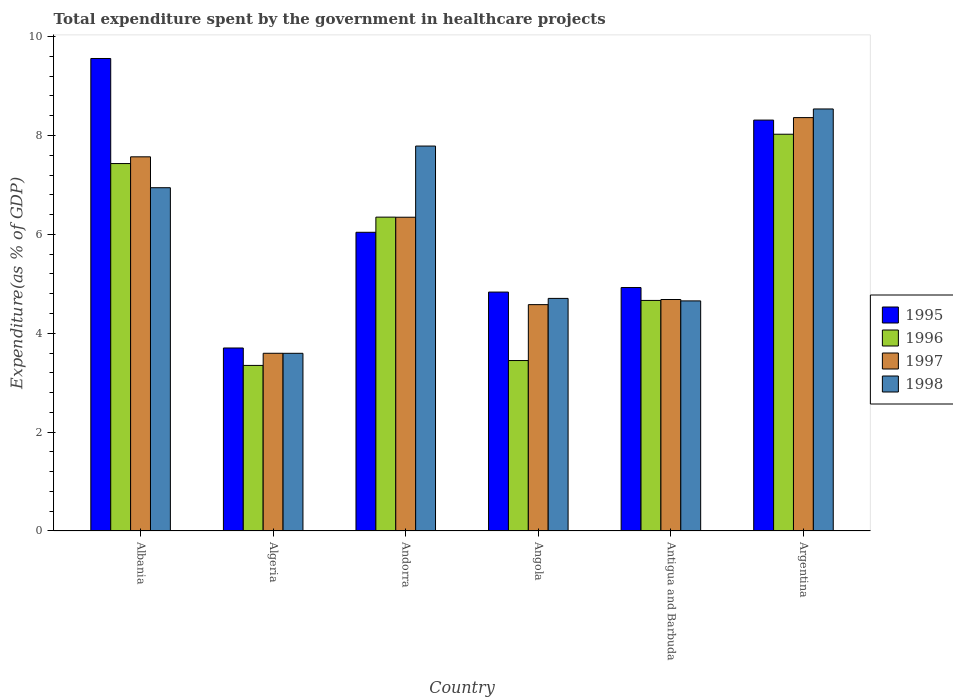How many groups of bars are there?
Your answer should be compact. 6. Are the number of bars per tick equal to the number of legend labels?
Your response must be concise. Yes. Are the number of bars on each tick of the X-axis equal?
Your answer should be compact. Yes. How many bars are there on the 5th tick from the left?
Ensure brevity in your answer.  4. How many bars are there on the 3rd tick from the right?
Offer a very short reply. 4. What is the label of the 1st group of bars from the left?
Offer a terse response. Albania. What is the total expenditure spent by the government in healthcare projects in 1995 in Argentina?
Make the answer very short. 8.31. Across all countries, what is the maximum total expenditure spent by the government in healthcare projects in 1995?
Give a very brief answer. 9.56. Across all countries, what is the minimum total expenditure spent by the government in healthcare projects in 1997?
Your response must be concise. 3.59. In which country was the total expenditure spent by the government in healthcare projects in 1997 maximum?
Offer a very short reply. Argentina. In which country was the total expenditure spent by the government in healthcare projects in 1997 minimum?
Your response must be concise. Algeria. What is the total total expenditure spent by the government in healthcare projects in 1997 in the graph?
Ensure brevity in your answer.  35.13. What is the difference between the total expenditure spent by the government in healthcare projects in 1997 in Algeria and that in Andorra?
Provide a succinct answer. -2.75. What is the difference between the total expenditure spent by the government in healthcare projects in 1996 in Andorra and the total expenditure spent by the government in healthcare projects in 1998 in Albania?
Your answer should be very brief. -0.6. What is the average total expenditure spent by the government in healthcare projects in 1997 per country?
Your answer should be very brief. 5.86. What is the difference between the total expenditure spent by the government in healthcare projects of/in 1998 and total expenditure spent by the government in healthcare projects of/in 1995 in Algeria?
Offer a terse response. -0.11. In how many countries, is the total expenditure spent by the government in healthcare projects in 1998 greater than 9.2 %?
Offer a terse response. 0. What is the ratio of the total expenditure spent by the government in healthcare projects in 1995 in Andorra to that in Argentina?
Your response must be concise. 0.73. Is the total expenditure spent by the government in healthcare projects in 1998 in Algeria less than that in Antigua and Barbuda?
Offer a terse response. Yes. What is the difference between the highest and the second highest total expenditure spent by the government in healthcare projects in 1997?
Your response must be concise. 2.02. What is the difference between the highest and the lowest total expenditure spent by the government in healthcare projects in 1997?
Ensure brevity in your answer.  4.77. Is the sum of the total expenditure spent by the government in healthcare projects in 1996 in Albania and Argentina greater than the maximum total expenditure spent by the government in healthcare projects in 1997 across all countries?
Your answer should be compact. Yes. Is it the case that in every country, the sum of the total expenditure spent by the government in healthcare projects in 1998 and total expenditure spent by the government in healthcare projects in 1995 is greater than the total expenditure spent by the government in healthcare projects in 1996?
Offer a terse response. Yes. How many bars are there?
Provide a succinct answer. 24. How many countries are there in the graph?
Your answer should be very brief. 6. What is the difference between two consecutive major ticks on the Y-axis?
Ensure brevity in your answer.  2. Are the values on the major ticks of Y-axis written in scientific E-notation?
Make the answer very short. No. How many legend labels are there?
Make the answer very short. 4. How are the legend labels stacked?
Ensure brevity in your answer.  Vertical. What is the title of the graph?
Provide a succinct answer. Total expenditure spent by the government in healthcare projects. What is the label or title of the X-axis?
Make the answer very short. Country. What is the label or title of the Y-axis?
Give a very brief answer. Expenditure(as % of GDP). What is the Expenditure(as % of GDP) in 1995 in Albania?
Offer a very short reply. 9.56. What is the Expenditure(as % of GDP) in 1996 in Albania?
Your response must be concise. 7.43. What is the Expenditure(as % of GDP) of 1997 in Albania?
Offer a very short reply. 7.57. What is the Expenditure(as % of GDP) of 1998 in Albania?
Provide a short and direct response. 6.94. What is the Expenditure(as % of GDP) in 1995 in Algeria?
Offer a very short reply. 3.7. What is the Expenditure(as % of GDP) in 1996 in Algeria?
Provide a succinct answer. 3.35. What is the Expenditure(as % of GDP) of 1997 in Algeria?
Ensure brevity in your answer.  3.59. What is the Expenditure(as % of GDP) in 1998 in Algeria?
Keep it short and to the point. 3.59. What is the Expenditure(as % of GDP) of 1995 in Andorra?
Ensure brevity in your answer.  6.04. What is the Expenditure(as % of GDP) of 1996 in Andorra?
Ensure brevity in your answer.  6.35. What is the Expenditure(as % of GDP) in 1997 in Andorra?
Keep it short and to the point. 6.35. What is the Expenditure(as % of GDP) of 1998 in Andorra?
Keep it short and to the point. 7.79. What is the Expenditure(as % of GDP) of 1995 in Angola?
Your answer should be very brief. 4.83. What is the Expenditure(as % of GDP) in 1996 in Angola?
Your answer should be compact. 3.45. What is the Expenditure(as % of GDP) of 1997 in Angola?
Keep it short and to the point. 4.58. What is the Expenditure(as % of GDP) in 1998 in Angola?
Offer a terse response. 4.7. What is the Expenditure(as % of GDP) in 1995 in Antigua and Barbuda?
Your response must be concise. 4.92. What is the Expenditure(as % of GDP) of 1996 in Antigua and Barbuda?
Your answer should be compact. 4.66. What is the Expenditure(as % of GDP) in 1997 in Antigua and Barbuda?
Give a very brief answer. 4.68. What is the Expenditure(as % of GDP) in 1998 in Antigua and Barbuda?
Provide a succinct answer. 4.65. What is the Expenditure(as % of GDP) of 1995 in Argentina?
Give a very brief answer. 8.31. What is the Expenditure(as % of GDP) of 1996 in Argentina?
Keep it short and to the point. 8.02. What is the Expenditure(as % of GDP) of 1997 in Argentina?
Give a very brief answer. 8.36. What is the Expenditure(as % of GDP) in 1998 in Argentina?
Your answer should be compact. 8.54. Across all countries, what is the maximum Expenditure(as % of GDP) of 1995?
Give a very brief answer. 9.56. Across all countries, what is the maximum Expenditure(as % of GDP) of 1996?
Provide a short and direct response. 8.02. Across all countries, what is the maximum Expenditure(as % of GDP) of 1997?
Your response must be concise. 8.36. Across all countries, what is the maximum Expenditure(as % of GDP) in 1998?
Ensure brevity in your answer.  8.54. Across all countries, what is the minimum Expenditure(as % of GDP) in 1995?
Your answer should be very brief. 3.7. Across all countries, what is the minimum Expenditure(as % of GDP) of 1996?
Your response must be concise. 3.35. Across all countries, what is the minimum Expenditure(as % of GDP) of 1997?
Your response must be concise. 3.59. Across all countries, what is the minimum Expenditure(as % of GDP) in 1998?
Offer a terse response. 3.59. What is the total Expenditure(as % of GDP) of 1995 in the graph?
Keep it short and to the point. 37.37. What is the total Expenditure(as % of GDP) of 1996 in the graph?
Your response must be concise. 33.27. What is the total Expenditure(as % of GDP) in 1997 in the graph?
Offer a very short reply. 35.13. What is the total Expenditure(as % of GDP) in 1998 in the graph?
Make the answer very short. 36.22. What is the difference between the Expenditure(as % of GDP) of 1995 in Albania and that in Algeria?
Your answer should be compact. 5.86. What is the difference between the Expenditure(as % of GDP) of 1996 in Albania and that in Algeria?
Give a very brief answer. 4.08. What is the difference between the Expenditure(as % of GDP) of 1997 in Albania and that in Algeria?
Your response must be concise. 3.97. What is the difference between the Expenditure(as % of GDP) in 1998 in Albania and that in Algeria?
Offer a terse response. 3.35. What is the difference between the Expenditure(as % of GDP) of 1995 in Albania and that in Andorra?
Offer a terse response. 3.52. What is the difference between the Expenditure(as % of GDP) of 1996 in Albania and that in Andorra?
Give a very brief answer. 1.08. What is the difference between the Expenditure(as % of GDP) of 1997 in Albania and that in Andorra?
Keep it short and to the point. 1.22. What is the difference between the Expenditure(as % of GDP) of 1998 in Albania and that in Andorra?
Your answer should be very brief. -0.84. What is the difference between the Expenditure(as % of GDP) of 1995 in Albania and that in Angola?
Provide a short and direct response. 4.72. What is the difference between the Expenditure(as % of GDP) in 1996 in Albania and that in Angola?
Offer a terse response. 3.98. What is the difference between the Expenditure(as % of GDP) in 1997 in Albania and that in Angola?
Offer a terse response. 2.99. What is the difference between the Expenditure(as % of GDP) in 1998 in Albania and that in Angola?
Keep it short and to the point. 2.24. What is the difference between the Expenditure(as % of GDP) in 1995 in Albania and that in Antigua and Barbuda?
Offer a terse response. 4.63. What is the difference between the Expenditure(as % of GDP) of 1996 in Albania and that in Antigua and Barbuda?
Your answer should be compact. 2.77. What is the difference between the Expenditure(as % of GDP) in 1997 in Albania and that in Antigua and Barbuda?
Offer a very short reply. 2.89. What is the difference between the Expenditure(as % of GDP) of 1998 in Albania and that in Antigua and Barbuda?
Ensure brevity in your answer.  2.29. What is the difference between the Expenditure(as % of GDP) in 1995 in Albania and that in Argentina?
Offer a very short reply. 1.25. What is the difference between the Expenditure(as % of GDP) of 1996 in Albania and that in Argentina?
Give a very brief answer. -0.59. What is the difference between the Expenditure(as % of GDP) in 1997 in Albania and that in Argentina?
Make the answer very short. -0.79. What is the difference between the Expenditure(as % of GDP) of 1998 in Albania and that in Argentina?
Provide a succinct answer. -1.59. What is the difference between the Expenditure(as % of GDP) in 1995 in Algeria and that in Andorra?
Your answer should be very brief. -2.34. What is the difference between the Expenditure(as % of GDP) in 1996 in Algeria and that in Andorra?
Give a very brief answer. -3. What is the difference between the Expenditure(as % of GDP) of 1997 in Algeria and that in Andorra?
Offer a very short reply. -2.75. What is the difference between the Expenditure(as % of GDP) in 1998 in Algeria and that in Andorra?
Make the answer very short. -4.19. What is the difference between the Expenditure(as % of GDP) of 1995 in Algeria and that in Angola?
Your answer should be very brief. -1.13. What is the difference between the Expenditure(as % of GDP) of 1996 in Algeria and that in Angola?
Your response must be concise. -0.1. What is the difference between the Expenditure(as % of GDP) in 1997 in Algeria and that in Angola?
Your answer should be very brief. -0.98. What is the difference between the Expenditure(as % of GDP) of 1998 in Algeria and that in Angola?
Make the answer very short. -1.11. What is the difference between the Expenditure(as % of GDP) in 1995 in Algeria and that in Antigua and Barbuda?
Offer a terse response. -1.22. What is the difference between the Expenditure(as % of GDP) in 1996 in Algeria and that in Antigua and Barbuda?
Make the answer very short. -1.31. What is the difference between the Expenditure(as % of GDP) in 1997 in Algeria and that in Antigua and Barbuda?
Offer a terse response. -1.09. What is the difference between the Expenditure(as % of GDP) in 1998 in Algeria and that in Antigua and Barbuda?
Keep it short and to the point. -1.06. What is the difference between the Expenditure(as % of GDP) of 1995 in Algeria and that in Argentina?
Provide a succinct answer. -4.61. What is the difference between the Expenditure(as % of GDP) in 1996 in Algeria and that in Argentina?
Offer a terse response. -4.68. What is the difference between the Expenditure(as % of GDP) in 1997 in Algeria and that in Argentina?
Your response must be concise. -4.77. What is the difference between the Expenditure(as % of GDP) in 1998 in Algeria and that in Argentina?
Your answer should be compact. -4.94. What is the difference between the Expenditure(as % of GDP) in 1995 in Andorra and that in Angola?
Your response must be concise. 1.21. What is the difference between the Expenditure(as % of GDP) of 1996 in Andorra and that in Angola?
Your answer should be compact. 2.9. What is the difference between the Expenditure(as % of GDP) in 1997 in Andorra and that in Angola?
Offer a very short reply. 1.77. What is the difference between the Expenditure(as % of GDP) in 1998 in Andorra and that in Angola?
Provide a succinct answer. 3.08. What is the difference between the Expenditure(as % of GDP) in 1995 in Andorra and that in Antigua and Barbuda?
Make the answer very short. 1.12. What is the difference between the Expenditure(as % of GDP) in 1996 in Andorra and that in Antigua and Barbuda?
Offer a very short reply. 1.68. What is the difference between the Expenditure(as % of GDP) of 1997 in Andorra and that in Antigua and Barbuda?
Provide a short and direct response. 1.66. What is the difference between the Expenditure(as % of GDP) in 1998 in Andorra and that in Antigua and Barbuda?
Provide a short and direct response. 3.13. What is the difference between the Expenditure(as % of GDP) of 1995 in Andorra and that in Argentina?
Offer a terse response. -2.27. What is the difference between the Expenditure(as % of GDP) in 1996 in Andorra and that in Argentina?
Provide a succinct answer. -1.68. What is the difference between the Expenditure(as % of GDP) in 1997 in Andorra and that in Argentina?
Make the answer very short. -2.02. What is the difference between the Expenditure(as % of GDP) of 1998 in Andorra and that in Argentina?
Your response must be concise. -0.75. What is the difference between the Expenditure(as % of GDP) of 1995 in Angola and that in Antigua and Barbuda?
Your answer should be compact. -0.09. What is the difference between the Expenditure(as % of GDP) of 1996 in Angola and that in Antigua and Barbuda?
Keep it short and to the point. -1.22. What is the difference between the Expenditure(as % of GDP) in 1997 in Angola and that in Antigua and Barbuda?
Make the answer very short. -0.1. What is the difference between the Expenditure(as % of GDP) in 1998 in Angola and that in Antigua and Barbuda?
Give a very brief answer. 0.05. What is the difference between the Expenditure(as % of GDP) of 1995 in Angola and that in Argentina?
Offer a terse response. -3.48. What is the difference between the Expenditure(as % of GDP) of 1996 in Angola and that in Argentina?
Provide a succinct answer. -4.58. What is the difference between the Expenditure(as % of GDP) of 1997 in Angola and that in Argentina?
Your answer should be very brief. -3.78. What is the difference between the Expenditure(as % of GDP) of 1998 in Angola and that in Argentina?
Your answer should be compact. -3.83. What is the difference between the Expenditure(as % of GDP) of 1995 in Antigua and Barbuda and that in Argentina?
Make the answer very short. -3.39. What is the difference between the Expenditure(as % of GDP) in 1996 in Antigua and Barbuda and that in Argentina?
Ensure brevity in your answer.  -3.36. What is the difference between the Expenditure(as % of GDP) of 1997 in Antigua and Barbuda and that in Argentina?
Your answer should be compact. -3.68. What is the difference between the Expenditure(as % of GDP) of 1998 in Antigua and Barbuda and that in Argentina?
Your answer should be compact. -3.88. What is the difference between the Expenditure(as % of GDP) of 1995 in Albania and the Expenditure(as % of GDP) of 1996 in Algeria?
Make the answer very short. 6.21. What is the difference between the Expenditure(as % of GDP) in 1995 in Albania and the Expenditure(as % of GDP) in 1997 in Algeria?
Make the answer very short. 5.96. What is the difference between the Expenditure(as % of GDP) of 1995 in Albania and the Expenditure(as % of GDP) of 1998 in Algeria?
Ensure brevity in your answer.  5.96. What is the difference between the Expenditure(as % of GDP) in 1996 in Albania and the Expenditure(as % of GDP) in 1997 in Algeria?
Provide a short and direct response. 3.84. What is the difference between the Expenditure(as % of GDP) of 1996 in Albania and the Expenditure(as % of GDP) of 1998 in Algeria?
Your response must be concise. 3.84. What is the difference between the Expenditure(as % of GDP) in 1997 in Albania and the Expenditure(as % of GDP) in 1998 in Algeria?
Your response must be concise. 3.97. What is the difference between the Expenditure(as % of GDP) of 1995 in Albania and the Expenditure(as % of GDP) of 1996 in Andorra?
Your answer should be compact. 3.21. What is the difference between the Expenditure(as % of GDP) of 1995 in Albania and the Expenditure(as % of GDP) of 1997 in Andorra?
Offer a very short reply. 3.21. What is the difference between the Expenditure(as % of GDP) of 1995 in Albania and the Expenditure(as % of GDP) of 1998 in Andorra?
Provide a short and direct response. 1.77. What is the difference between the Expenditure(as % of GDP) in 1996 in Albania and the Expenditure(as % of GDP) in 1997 in Andorra?
Provide a short and direct response. 1.09. What is the difference between the Expenditure(as % of GDP) in 1996 in Albania and the Expenditure(as % of GDP) in 1998 in Andorra?
Offer a terse response. -0.35. What is the difference between the Expenditure(as % of GDP) in 1997 in Albania and the Expenditure(as % of GDP) in 1998 in Andorra?
Keep it short and to the point. -0.22. What is the difference between the Expenditure(as % of GDP) in 1995 in Albania and the Expenditure(as % of GDP) in 1996 in Angola?
Give a very brief answer. 6.11. What is the difference between the Expenditure(as % of GDP) of 1995 in Albania and the Expenditure(as % of GDP) of 1997 in Angola?
Give a very brief answer. 4.98. What is the difference between the Expenditure(as % of GDP) of 1995 in Albania and the Expenditure(as % of GDP) of 1998 in Angola?
Make the answer very short. 4.85. What is the difference between the Expenditure(as % of GDP) in 1996 in Albania and the Expenditure(as % of GDP) in 1997 in Angola?
Provide a succinct answer. 2.85. What is the difference between the Expenditure(as % of GDP) in 1996 in Albania and the Expenditure(as % of GDP) in 1998 in Angola?
Offer a very short reply. 2.73. What is the difference between the Expenditure(as % of GDP) of 1997 in Albania and the Expenditure(as % of GDP) of 1998 in Angola?
Give a very brief answer. 2.86. What is the difference between the Expenditure(as % of GDP) in 1995 in Albania and the Expenditure(as % of GDP) in 1996 in Antigua and Barbuda?
Provide a short and direct response. 4.89. What is the difference between the Expenditure(as % of GDP) in 1995 in Albania and the Expenditure(as % of GDP) in 1997 in Antigua and Barbuda?
Ensure brevity in your answer.  4.87. What is the difference between the Expenditure(as % of GDP) in 1995 in Albania and the Expenditure(as % of GDP) in 1998 in Antigua and Barbuda?
Give a very brief answer. 4.9. What is the difference between the Expenditure(as % of GDP) of 1996 in Albania and the Expenditure(as % of GDP) of 1997 in Antigua and Barbuda?
Offer a very short reply. 2.75. What is the difference between the Expenditure(as % of GDP) in 1996 in Albania and the Expenditure(as % of GDP) in 1998 in Antigua and Barbuda?
Ensure brevity in your answer.  2.78. What is the difference between the Expenditure(as % of GDP) in 1997 in Albania and the Expenditure(as % of GDP) in 1998 in Antigua and Barbuda?
Provide a short and direct response. 2.91. What is the difference between the Expenditure(as % of GDP) in 1995 in Albania and the Expenditure(as % of GDP) in 1996 in Argentina?
Provide a succinct answer. 1.53. What is the difference between the Expenditure(as % of GDP) in 1995 in Albania and the Expenditure(as % of GDP) in 1997 in Argentina?
Keep it short and to the point. 1.2. What is the difference between the Expenditure(as % of GDP) in 1995 in Albania and the Expenditure(as % of GDP) in 1998 in Argentina?
Ensure brevity in your answer.  1.02. What is the difference between the Expenditure(as % of GDP) in 1996 in Albania and the Expenditure(as % of GDP) in 1997 in Argentina?
Keep it short and to the point. -0.93. What is the difference between the Expenditure(as % of GDP) in 1996 in Albania and the Expenditure(as % of GDP) in 1998 in Argentina?
Make the answer very short. -1.1. What is the difference between the Expenditure(as % of GDP) of 1997 in Albania and the Expenditure(as % of GDP) of 1998 in Argentina?
Provide a short and direct response. -0.97. What is the difference between the Expenditure(as % of GDP) in 1995 in Algeria and the Expenditure(as % of GDP) in 1996 in Andorra?
Your response must be concise. -2.65. What is the difference between the Expenditure(as % of GDP) in 1995 in Algeria and the Expenditure(as % of GDP) in 1997 in Andorra?
Ensure brevity in your answer.  -2.64. What is the difference between the Expenditure(as % of GDP) of 1995 in Algeria and the Expenditure(as % of GDP) of 1998 in Andorra?
Offer a terse response. -4.08. What is the difference between the Expenditure(as % of GDP) in 1996 in Algeria and the Expenditure(as % of GDP) in 1997 in Andorra?
Make the answer very short. -3. What is the difference between the Expenditure(as % of GDP) of 1996 in Algeria and the Expenditure(as % of GDP) of 1998 in Andorra?
Ensure brevity in your answer.  -4.44. What is the difference between the Expenditure(as % of GDP) of 1997 in Algeria and the Expenditure(as % of GDP) of 1998 in Andorra?
Keep it short and to the point. -4.19. What is the difference between the Expenditure(as % of GDP) of 1995 in Algeria and the Expenditure(as % of GDP) of 1996 in Angola?
Offer a terse response. 0.25. What is the difference between the Expenditure(as % of GDP) of 1995 in Algeria and the Expenditure(as % of GDP) of 1997 in Angola?
Your response must be concise. -0.88. What is the difference between the Expenditure(as % of GDP) of 1995 in Algeria and the Expenditure(as % of GDP) of 1998 in Angola?
Make the answer very short. -1. What is the difference between the Expenditure(as % of GDP) of 1996 in Algeria and the Expenditure(as % of GDP) of 1997 in Angola?
Keep it short and to the point. -1.23. What is the difference between the Expenditure(as % of GDP) in 1996 in Algeria and the Expenditure(as % of GDP) in 1998 in Angola?
Offer a very short reply. -1.36. What is the difference between the Expenditure(as % of GDP) in 1997 in Algeria and the Expenditure(as % of GDP) in 1998 in Angola?
Offer a terse response. -1.11. What is the difference between the Expenditure(as % of GDP) in 1995 in Algeria and the Expenditure(as % of GDP) in 1996 in Antigua and Barbuda?
Keep it short and to the point. -0.96. What is the difference between the Expenditure(as % of GDP) of 1995 in Algeria and the Expenditure(as % of GDP) of 1997 in Antigua and Barbuda?
Give a very brief answer. -0.98. What is the difference between the Expenditure(as % of GDP) of 1995 in Algeria and the Expenditure(as % of GDP) of 1998 in Antigua and Barbuda?
Keep it short and to the point. -0.95. What is the difference between the Expenditure(as % of GDP) in 1996 in Algeria and the Expenditure(as % of GDP) in 1997 in Antigua and Barbuda?
Give a very brief answer. -1.33. What is the difference between the Expenditure(as % of GDP) in 1996 in Algeria and the Expenditure(as % of GDP) in 1998 in Antigua and Barbuda?
Offer a terse response. -1.3. What is the difference between the Expenditure(as % of GDP) in 1997 in Algeria and the Expenditure(as % of GDP) in 1998 in Antigua and Barbuda?
Your response must be concise. -1.06. What is the difference between the Expenditure(as % of GDP) of 1995 in Algeria and the Expenditure(as % of GDP) of 1996 in Argentina?
Provide a short and direct response. -4.32. What is the difference between the Expenditure(as % of GDP) in 1995 in Algeria and the Expenditure(as % of GDP) in 1997 in Argentina?
Offer a very short reply. -4.66. What is the difference between the Expenditure(as % of GDP) in 1995 in Algeria and the Expenditure(as % of GDP) in 1998 in Argentina?
Your response must be concise. -4.83. What is the difference between the Expenditure(as % of GDP) in 1996 in Algeria and the Expenditure(as % of GDP) in 1997 in Argentina?
Give a very brief answer. -5.01. What is the difference between the Expenditure(as % of GDP) of 1996 in Algeria and the Expenditure(as % of GDP) of 1998 in Argentina?
Offer a terse response. -5.19. What is the difference between the Expenditure(as % of GDP) of 1997 in Algeria and the Expenditure(as % of GDP) of 1998 in Argentina?
Ensure brevity in your answer.  -4.94. What is the difference between the Expenditure(as % of GDP) of 1995 in Andorra and the Expenditure(as % of GDP) of 1996 in Angola?
Offer a terse response. 2.59. What is the difference between the Expenditure(as % of GDP) of 1995 in Andorra and the Expenditure(as % of GDP) of 1997 in Angola?
Offer a terse response. 1.46. What is the difference between the Expenditure(as % of GDP) in 1995 in Andorra and the Expenditure(as % of GDP) in 1998 in Angola?
Ensure brevity in your answer.  1.34. What is the difference between the Expenditure(as % of GDP) of 1996 in Andorra and the Expenditure(as % of GDP) of 1997 in Angola?
Keep it short and to the point. 1.77. What is the difference between the Expenditure(as % of GDP) in 1996 in Andorra and the Expenditure(as % of GDP) in 1998 in Angola?
Your answer should be very brief. 1.64. What is the difference between the Expenditure(as % of GDP) of 1997 in Andorra and the Expenditure(as % of GDP) of 1998 in Angola?
Make the answer very short. 1.64. What is the difference between the Expenditure(as % of GDP) in 1995 in Andorra and the Expenditure(as % of GDP) in 1996 in Antigua and Barbuda?
Provide a succinct answer. 1.38. What is the difference between the Expenditure(as % of GDP) in 1995 in Andorra and the Expenditure(as % of GDP) in 1997 in Antigua and Barbuda?
Provide a short and direct response. 1.36. What is the difference between the Expenditure(as % of GDP) of 1995 in Andorra and the Expenditure(as % of GDP) of 1998 in Antigua and Barbuda?
Provide a short and direct response. 1.39. What is the difference between the Expenditure(as % of GDP) in 1996 in Andorra and the Expenditure(as % of GDP) in 1997 in Antigua and Barbuda?
Give a very brief answer. 1.67. What is the difference between the Expenditure(as % of GDP) in 1996 in Andorra and the Expenditure(as % of GDP) in 1998 in Antigua and Barbuda?
Your answer should be very brief. 1.69. What is the difference between the Expenditure(as % of GDP) of 1997 in Andorra and the Expenditure(as % of GDP) of 1998 in Antigua and Barbuda?
Make the answer very short. 1.69. What is the difference between the Expenditure(as % of GDP) of 1995 in Andorra and the Expenditure(as % of GDP) of 1996 in Argentina?
Provide a succinct answer. -1.98. What is the difference between the Expenditure(as % of GDP) in 1995 in Andorra and the Expenditure(as % of GDP) in 1997 in Argentina?
Offer a very short reply. -2.32. What is the difference between the Expenditure(as % of GDP) of 1995 in Andorra and the Expenditure(as % of GDP) of 1998 in Argentina?
Your response must be concise. -2.49. What is the difference between the Expenditure(as % of GDP) of 1996 in Andorra and the Expenditure(as % of GDP) of 1997 in Argentina?
Offer a terse response. -2.01. What is the difference between the Expenditure(as % of GDP) of 1996 in Andorra and the Expenditure(as % of GDP) of 1998 in Argentina?
Ensure brevity in your answer.  -2.19. What is the difference between the Expenditure(as % of GDP) in 1997 in Andorra and the Expenditure(as % of GDP) in 1998 in Argentina?
Give a very brief answer. -2.19. What is the difference between the Expenditure(as % of GDP) of 1995 in Angola and the Expenditure(as % of GDP) of 1996 in Antigua and Barbuda?
Your response must be concise. 0.17. What is the difference between the Expenditure(as % of GDP) of 1995 in Angola and the Expenditure(as % of GDP) of 1997 in Antigua and Barbuda?
Your answer should be very brief. 0.15. What is the difference between the Expenditure(as % of GDP) of 1995 in Angola and the Expenditure(as % of GDP) of 1998 in Antigua and Barbuda?
Your response must be concise. 0.18. What is the difference between the Expenditure(as % of GDP) in 1996 in Angola and the Expenditure(as % of GDP) in 1997 in Antigua and Barbuda?
Offer a very short reply. -1.23. What is the difference between the Expenditure(as % of GDP) in 1996 in Angola and the Expenditure(as % of GDP) in 1998 in Antigua and Barbuda?
Ensure brevity in your answer.  -1.21. What is the difference between the Expenditure(as % of GDP) in 1997 in Angola and the Expenditure(as % of GDP) in 1998 in Antigua and Barbuda?
Provide a succinct answer. -0.08. What is the difference between the Expenditure(as % of GDP) of 1995 in Angola and the Expenditure(as % of GDP) of 1996 in Argentina?
Give a very brief answer. -3.19. What is the difference between the Expenditure(as % of GDP) in 1995 in Angola and the Expenditure(as % of GDP) in 1997 in Argentina?
Keep it short and to the point. -3.53. What is the difference between the Expenditure(as % of GDP) in 1995 in Angola and the Expenditure(as % of GDP) in 1998 in Argentina?
Give a very brief answer. -3.7. What is the difference between the Expenditure(as % of GDP) in 1996 in Angola and the Expenditure(as % of GDP) in 1997 in Argentina?
Ensure brevity in your answer.  -4.91. What is the difference between the Expenditure(as % of GDP) in 1996 in Angola and the Expenditure(as % of GDP) in 1998 in Argentina?
Provide a short and direct response. -5.09. What is the difference between the Expenditure(as % of GDP) in 1997 in Angola and the Expenditure(as % of GDP) in 1998 in Argentina?
Offer a very short reply. -3.96. What is the difference between the Expenditure(as % of GDP) of 1995 in Antigua and Barbuda and the Expenditure(as % of GDP) of 1996 in Argentina?
Offer a terse response. -3.1. What is the difference between the Expenditure(as % of GDP) in 1995 in Antigua and Barbuda and the Expenditure(as % of GDP) in 1997 in Argentina?
Your answer should be very brief. -3.44. What is the difference between the Expenditure(as % of GDP) of 1995 in Antigua and Barbuda and the Expenditure(as % of GDP) of 1998 in Argentina?
Keep it short and to the point. -3.61. What is the difference between the Expenditure(as % of GDP) in 1996 in Antigua and Barbuda and the Expenditure(as % of GDP) in 1997 in Argentina?
Offer a very short reply. -3.7. What is the difference between the Expenditure(as % of GDP) in 1996 in Antigua and Barbuda and the Expenditure(as % of GDP) in 1998 in Argentina?
Make the answer very short. -3.87. What is the difference between the Expenditure(as % of GDP) in 1997 in Antigua and Barbuda and the Expenditure(as % of GDP) in 1998 in Argentina?
Your answer should be compact. -3.85. What is the average Expenditure(as % of GDP) of 1995 per country?
Offer a very short reply. 6.23. What is the average Expenditure(as % of GDP) of 1996 per country?
Provide a succinct answer. 5.54. What is the average Expenditure(as % of GDP) in 1997 per country?
Make the answer very short. 5.86. What is the average Expenditure(as % of GDP) of 1998 per country?
Ensure brevity in your answer.  6.04. What is the difference between the Expenditure(as % of GDP) of 1995 and Expenditure(as % of GDP) of 1996 in Albania?
Your response must be concise. 2.12. What is the difference between the Expenditure(as % of GDP) in 1995 and Expenditure(as % of GDP) in 1997 in Albania?
Your answer should be very brief. 1.99. What is the difference between the Expenditure(as % of GDP) of 1995 and Expenditure(as % of GDP) of 1998 in Albania?
Your response must be concise. 2.61. What is the difference between the Expenditure(as % of GDP) of 1996 and Expenditure(as % of GDP) of 1997 in Albania?
Your answer should be compact. -0.14. What is the difference between the Expenditure(as % of GDP) of 1996 and Expenditure(as % of GDP) of 1998 in Albania?
Your answer should be compact. 0.49. What is the difference between the Expenditure(as % of GDP) of 1997 and Expenditure(as % of GDP) of 1998 in Albania?
Your response must be concise. 0.62. What is the difference between the Expenditure(as % of GDP) of 1995 and Expenditure(as % of GDP) of 1996 in Algeria?
Give a very brief answer. 0.35. What is the difference between the Expenditure(as % of GDP) of 1995 and Expenditure(as % of GDP) of 1997 in Algeria?
Provide a succinct answer. 0.11. What is the difference between the Expenditure(as % of GDP) of 1995 and Expenditure(as % of GDP) of 1998 in Algeria?
Ensure brevity in your answer.  0.11. What is the difference between the Expenditure(as % of GDP) of 1996 and Expenditure(as % of GDP) of 1997 in Algeria?
Give a very brief answer. -0.25. What is the difference between the Expenditure(as % of GDP) in 1996 and Expenditure(as % of GDP) in 1998 in Algeria?
Ensure brevity in your answer.  -0.24. What is the difference between the Expenditure(as % of GDP) of 1997 and Expenditure(as % of GDP) of 1998 in Algeria?
Ensure brevity in your answer.  0. What is the difference between the Expenditure(as % of GDP) in 1995 and Expenditure(as % of GDP) in 1996 in Andorra?
Your response must be concise. -0.31. What is the difference between the Expenditure(as % of GDP) in 1995 and Expenditure(as % of GDP) in 1997 in Andorra?
Offer a terse response. -0.3. What is the difference between the Expenditure(as % of GDP) of 1995 and Expenditure(as % of GDP) of 1998 in Andorra?
Offer a terse response. -1.74. What is the difference between the Expenditure(as % of GDP) in 1996 and Expenditure(as % of GDP) in 1997 in Andorra?
Your response must be concise. 0. What is the difference between the Expenditure(as % of GDP) of 1996 and Expenditure(as % of GDP) of 1998 in Andorra?
Give a very brief answer. -1.44. What is the difference between the Expenditure(as % of GDP) of 1997 and Expenditure(as % of GDP) of 1998 in Andorra?
Provide a short and direct response. -1.44. What is the difference between the Expenditure(as % of GDP) in 1995 and Expenditure(as % of GDP) in 1996 in Angola?
Your answer should be very brief. 1.38. What is the difference between the Expenditure(as % of GDP) of 1995 and Expenditure(as % of GDP) of 1997 in Angola?
Give a very brief answer. 0.25. What is the difference between the Expenditure(as % of GDP) of 1995 and Expenditure(as % of GDP) of 1998 in Angola?
Offer a terse response. 0.13. What is the difference between the Expenditure(as % of GDP) in 1996 and Expenditure(as % of GDP) in 1997 in Angola?
Provide a succinct answer. -1.13. What is the difference between the Expenditure(as % of GDP) of 1996 and Expenditure(as % of GDP) of 1998 in Angola?
Provide a short and direct response. -1.26. What is the difference between the Expenditure(as % of GDP) in 1997 and Expenditure(as % of GDP) in 1998 in Angola?
Make the answer very short. -0.13. What is the difference between the Expenditure(as % of GDP) of 1995 and Expenditure(as % of GDP) of 1996 in Antigua and Barbuda?
Provide a succinct answer. 0.26. What is the difference between the Expenditure(as % of GDP) in 1995 and Expenditure(as % of GDP) in 1997 in Antigua and Barbuda?
Keep it short and to the point. 0.24. What is the difference between the Expenditure(as % of GDP) in 1995 and Expenditure(as % of GDP) in 1998 in Antigua and Barbuda?
Make the answer very short. 0.27. What is the difference between the Expenditure(as % of GDP) in 1996 and Expenditure(as % of GDP) in 1997 in Antigua and Barbuda?
Make the answer very short. -0.02. What is the difference between the Expenditure(as % of GDP) of 1996 and Expenditure(as % of GDP) of 1998 in Antigua and Barbuda?
Your answer should be compact. 0.01. What is the difference between the Expenditure(as % of GDP) of 1997 and Expenditure(as % of GDP) of 1998 in Antigua and Barbuda?
Provide a succinct answer. 0.03. What is the difference between the Expenditure(as % of GDP) in 1995 and Expenditure(as % of GDP) in 1996 in Argentina?
Offer a terse response. 0.29. What is the difference between the Expenditure(as % of GDP) in 1995 and Expenditure(as % of GDP) in 1997 in Argentina?
Provide a short and direct response. -0.05. What is the difference between the Expenditure(as % of GDP) of 1995 and Expenditure(as % of GDP) of 1998 in Argentina?
Make the answer very short. -0.22. What is the difference between the Expenditure(as % of GDP) in 1996 and Expenditure(as % of GDP) in 1997 in Argentina?
Offer a terse response. -0.34. What is the difference between the Expenditure(as % of GDP) of 1996 and Expenditure(as % of GDP) of 1998 in Argentina?
Your response must be concise. -0.51. What is the difference between the Expenditure(as % of GDP) in 1997 and Expenditure(as % of GDP) in 1998 in Argentina?
Your response must be concise. -0.17. What is the ratio of the Expenditure(as % of GDP) of 1995 in Albania to that in Algeria?
Your answer should be compact. 2.58. What is the ratio of the Expenditure(as % of GDP) in 1996 in Albania to that in Algeria?
Your answer should be compact. 2.22. What is the ratio of the Expenditure(as % of GDP) in 1997 in Albania to that in Algeria?
Your response must be concise. 2.11. What is the ratio of the Expenditure(as % of GDP) in 1998 in Albania to that in Algeria?
Ensure brevity in your answer.  1.93. What is the ratio of the Expenditure(as % of GDP) of 1995 in Albania to that in Andorra?
Keep it short and to the point. 1.58. What is the ratio of the Expenditure(as % of GDP) in 1996 in Albania to that in Andorra?
Offer a terse response. 1.17. What is the ratio of the Expenditure(as % of GDP) of 1997 in Albania to that in Andorra?
Your response must be concise. 1.19. What is the ratio of the Expenditure(as % of GDP) of 1998 in Albania to that in Andorra?
Provide a short and direct response. 0.89. What is the ratio of the Expenditure(as % of GDP) in 1995 in Albania to that in Angola?
Your response must be concise. 1.98. What is the ratio of the Expenditure(as % of GDP) of 1996 in Albania to that in Angola?
Provide a succinct answer. 2.16. What is the ratio of the Expenditure(as % of GDP) in 1997 in Albania to that in Angola?
Make the answer very short. 1.65. What is the ratio of the Expenditure(as % of GDP) of 1998 in Albania to that in Angola?
Your answer should be compact. 1.48. What is the ratio of the Expenditure(as % of GDP) in 1995 in Albania to that in Antigua and Barbuda?
Provide a short and direct response. 1.94. What is the ratio of the Expenditure(as % of GDP) in 1996 in Albania to that in Antigua and Barbuda?
Your response must be concise. 1.59. What is the ratio of the Expenditure(as % of GDP) of 1997 in Albania to that in Antigua and Barbuda?
Offer a very short reply. 1.62. What is the ratio of the Expenditure(as % of GDP) of 1998 in Albania to that in Antigua and Barbuda?
Provide a succinct answer. 1.49. What is the ratio of the Expenditure(as % of GDP) of 1995 in Albania to that in Argentina?
Your response must be concise. 1.15. What is the ratio of the Expenditure(as % of GDP) of 1996 in Albania to that in Argentina?
Your answer should be very brief. 0.93. What is the ratio of the Expenditure(as % of GDP) of 1997 in Albania to that in Argentina?
Make the answer very short. 0.91. What is the ratio of the Expenditure(as % of GDP) of 1998 in Albania to that in Argentina?
Keep it short and to the point. 0.81. What is the ratio of the Expenditure(as % of GDP) of 1995 in Algeria to that in Andorra?
Keep it short and to the point. 0.61. What is the ratio of the Expenditure(as % of GDP) in 1996 in Algeria to that in Andorra?
Offer a terse response. 0.53. What is the ratio of the Expenditure(as % of GDP) in 1997 in Algeria to that in Andorra?
Ensure brevity in your answer.  0.57. What is the ratio of the Expenditure(as % of GDP) in 1998 in Algeria to that in Andorra?
Offer a very short reply. 0.46. What is the ratio of the Expenditure(as % of GDP) of 1995 in Algeria to that in Angola?
Make the answer very short. 0.77. What is the ratio of the Expenditure(as % of GDP) of 1996 in Algeria to that in Angola?
Offer a terse response. 0.97. What is the ratio of the Expenditure(as % of GDP) of 1997 in Algeria to that in Angola?
Make the answer very short. 0.79. What is the ratio of the Expenditure(as % of GDP) in 1998 in Algeria to that in Angola?
Offer a terse response. 0.76. What is the ratio of the Expenditure(as % of GDP) in 1995 in Algeria to that in Antigua and Barbuda?
Provide a succinct answer. 0.75. What is the ratio of the Expenditure(as % of GDP) of 1996 in Algeria to that in Antigua and Barbuda?
Your response must be concise. 0.72. What is the ratio of the Expenditure(as % of GDP) in 1997 in Algeria to that in Antigua and Barbuda?
Make the answer very short. 0.77. What is the ratio of the Expenditure(as % of GDP) of 1998 in Algeria to that in Antigua and Barbuda?
Give a very brief answer. 0.77. What is the ratio of the Expenditure(as % of GDP) of 1995 in Algeria to that in Argentina?
Make the answer very short. 0.45. What is the ratio of the Expenditure(as % of GDP) of 1996 in Algeria to that in Argentina?
Make the answer very short. 0.42. What is the ratio of the Expenditure(as % of GDP) in 1997 in Algeria to that in Argentina?
Your answer should be compact. 0.43. What is the ratio of the Expenditure(as % of GDP) in 1998 in Algeria to that in Argentina?
Provide a succinct answer. 0.42. What is the ratio of the Expenditure(as % of GDP) of 1995 in Andorra to that in Angola?
Your response must be concise. 1.25. What is the ratio of the Expenditure(as % of GDP) of 1996 in Andorra to that in Angola?
Offer a very short reply. 1.84. What is the ratio of the Expenditure(as % of GDP) of 1997 in Andorra to that in Angola?
Make the answer very short. 1.39. What is the ratio of the Expenditure(as % of GDP) in 1998 in Andorra to that in Angola?
Offer a terse response. 1.65. What is the ratio of the Expenditure(as % of GDP) in 1995 in Andorra to that in Antigua and Barbuda?
Provide a short and direct response. 1.23. What is the ratio of the Expenditure(as % of GDP) of 1996 in Andorra to that in Antigua and Barbuda?
Provide a short and direct response. 1.36. What is the ratio of the Expenditure(as % of GDP) in 1997 in Andorra to that in Antigua and Barbuda?
Keep it short and to the point. 1.36. What is the ratio of the Expenditure(as % of GDP) of 1998 in Andorra to that in Antigua and Barbuda?
Keep it short and to the point. 1.67. What is the ratio of the Expenditure(as % of GDP) of 1995 in Andorra to that in Argentina?
Give a very brief answer. 0.73. What is the ratio of the Expenditure(as % of GDP) in 1996 in Andorra to that in Argentina?
Your response must be concise. 0.79. What is the ratio of the Expenditure(as % of GDP) of 1997 in Andorra to that in Argentina?
Your response must be concise. 0.76. What is the ratio of the Expenditure(as % of GDP) of 1998 in Andorra to that in Argentina?
Offer a terse response. 0.91. What is the ratio of the Expenditure(as % of GDP) in 1995 in Angola to that in Antigua and Barbuda?
Offer a terse response. 0.98. What is the ratio of the Expenditure(as % of GDP) in 1996 in Angola to that in Antigua and Barbuda?
Provide a succinct answer. 0.74. What is the ratio of the Expenditure(as % of GDP) in 1997 in Angola to that in Antigua and Barbuda?
Offer a very short reply. 0.98. What is the ratio of the Expenditure(as % of GDP) of 1998 in Angola to that in Antigua and Barbuda?
Make the answer very short. 1.01. What is the ratio of the Expenditure(as % of GDP) of 1995 in Angola to that in Argentina?
Your answer should be compact. 0.58. What is the ratio of the Expenditure(as % of GDP) of 1996 in Angola to that in Argentina?
Make the answer very short. 0.43. What is the ratio of the Expenditure(as % of GDP) in 1997 in Angola to that in Argentina?
Offer a terse response. 0.55. What is the ratio of the Expenditure(as % of GDP) in 1998 in Angola to that in Argentina?
Provide a short and direct response. 0.55. What is the ratio of the Expenditure(as % of GDP) in 1995 in Antigua and Barbuda to that in Argentina?
Your answer should be very brief. 0.59. What is the ratio of the Expenditure(as % of GDP) in 1996 in Antigua and Barbuda to that in Argentina?
Provide a succinct answer. 0.58. What is the ratio of the Expenditure(as % of GDP) in 1997 in Antigua and Barbuda to that in Argentina?
Ensure brevity in your answer.  0.56. What is the ratio of the Expenditure(as % of GDP) in 1998 in Antigua and Barbuda to that in Argentina?
Your answer should be compact. 0.55. What is the difference between the highest and the second highest Expenditure(as % of GDP) in 1995?
Make the answer very short. 1.25. What is the difference between the highest and the second highest Expenditure(as % of GDP) of 1996?
Ensure brevity in your answer.  0.59. What is the difference between the highest and the second highest Expenditure(as % of GDP) of 1997?
Provide a short and direct response. 0.79. What is the difference between the highest and the second highest Expenditure(as % of GDP) of 1998?
Your response must be concise. 0.75. What is the difference between the highest and the lowest Expenditure(as % of GDP) in 1995?
Provide a succinct answer. 5.86. What is the difference between the highest and the lowest Expenditure(as % of GDP) of 1996?
Offer a terse response. 4.68. What is the difference between the highest and the lowest Expenditure(as % of GDP) in 1997?
Keep it short and to the point. 4.77. What is the difference between the highest and the lowest Expenditure(as % of GDP) in 1998?
Your answer should be compact. 4.94. 